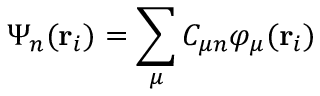<formula> <loc_0><loc_0><loc_500><loc_500>\Psi _ { n } ( r _ { i } ) = \sum _ { \mu } C _ { \mu n } \varphi _ { \mu } ( r _ { i } )</formula> 